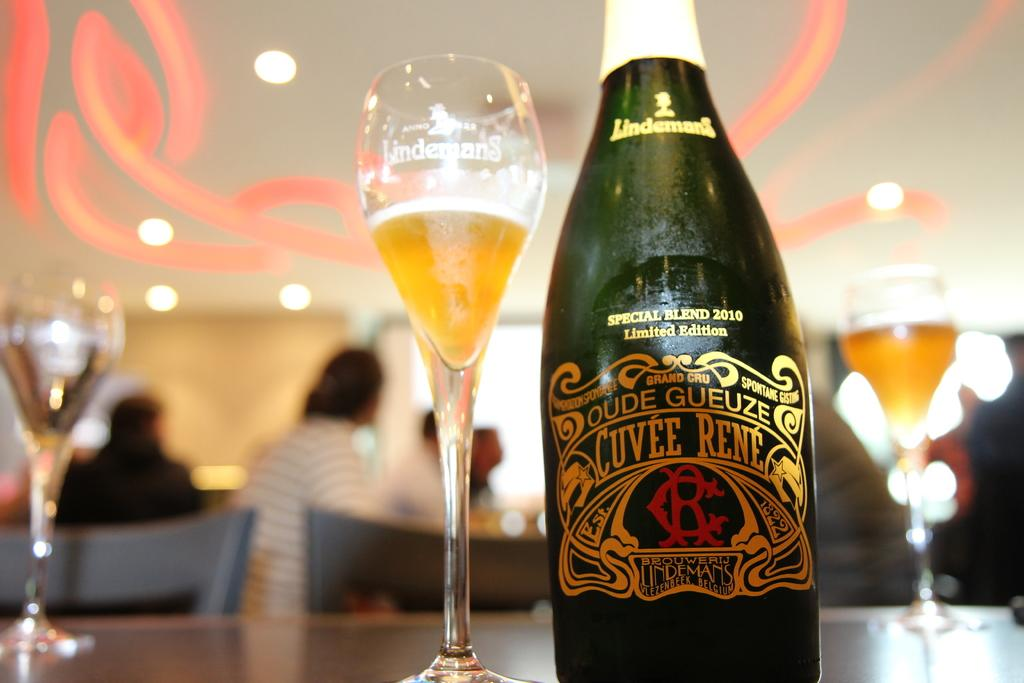<image>
Relay a brief, clear account of the picture shown. Bottle of wine which says "Cuvee Rene" on it. 